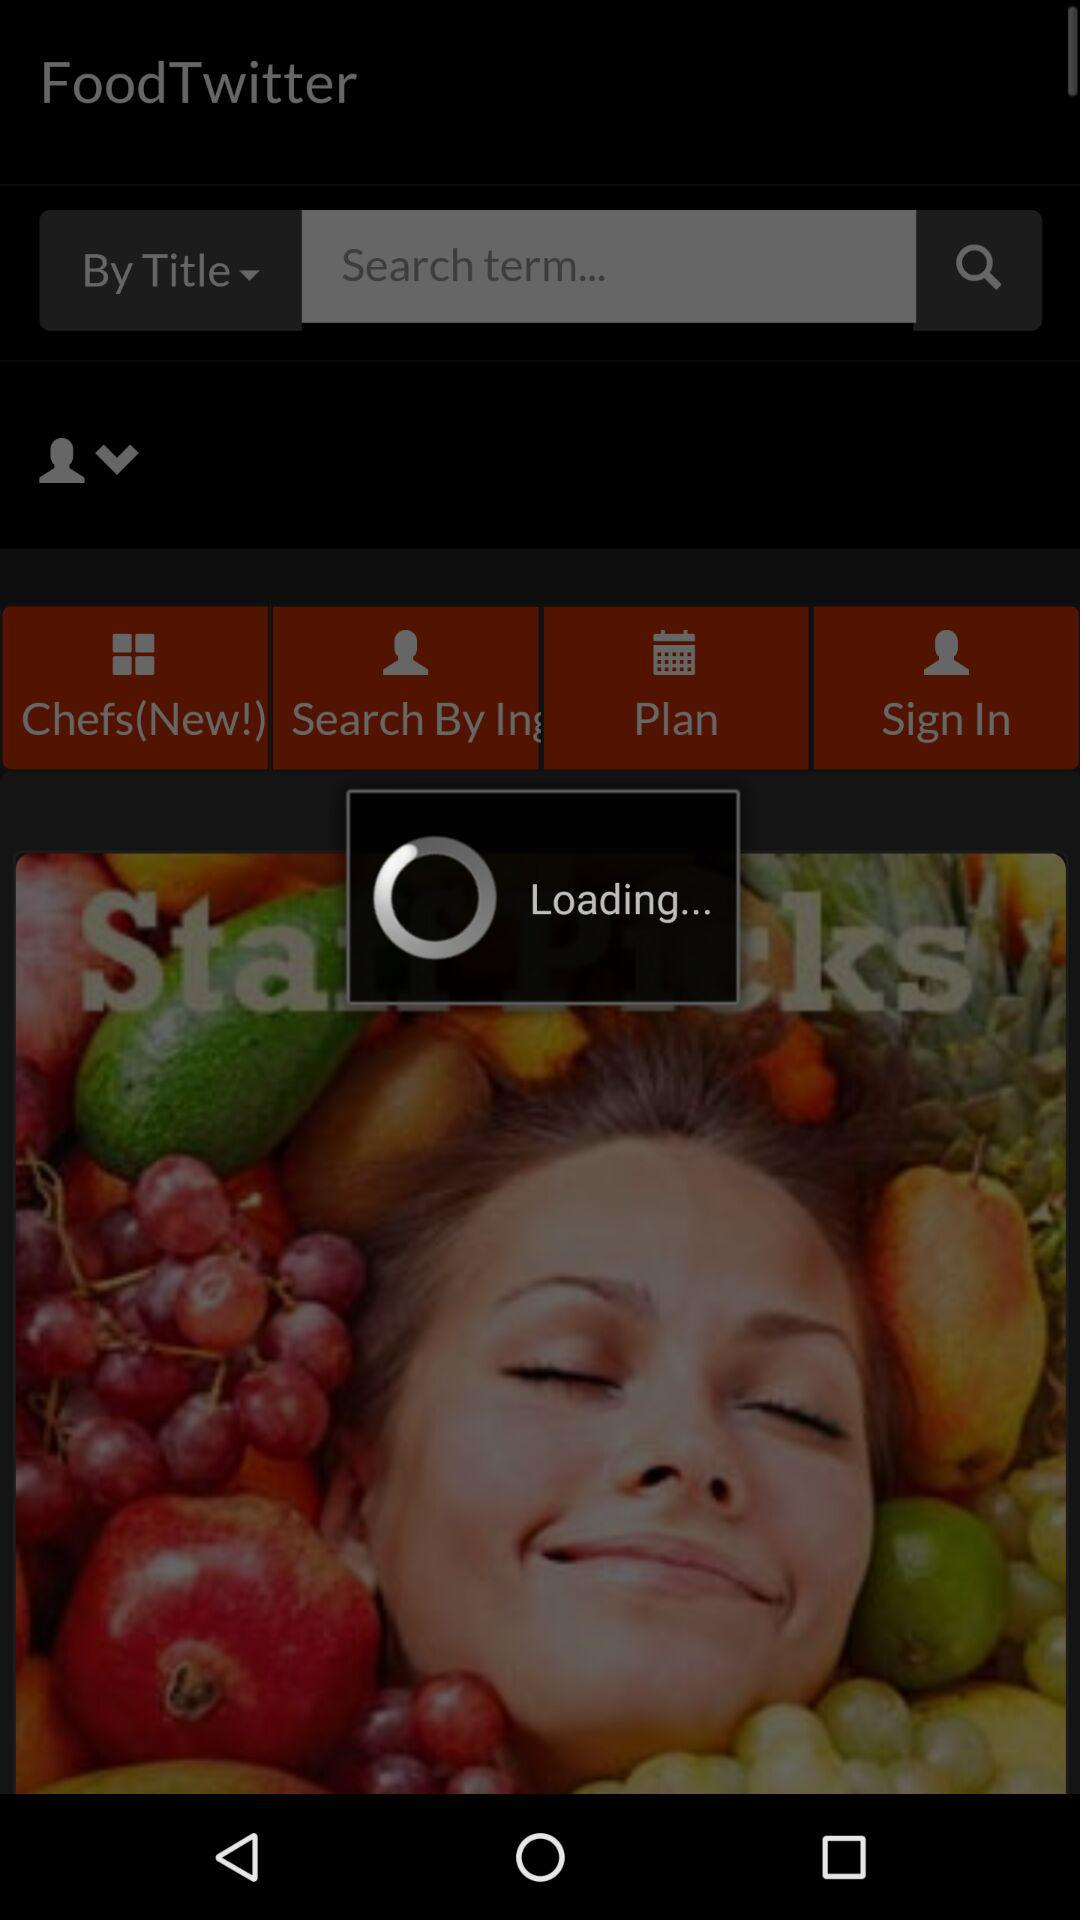What is the name of the recipe? The name of the recipe is Goat Cheese Chorizo Rolls. 